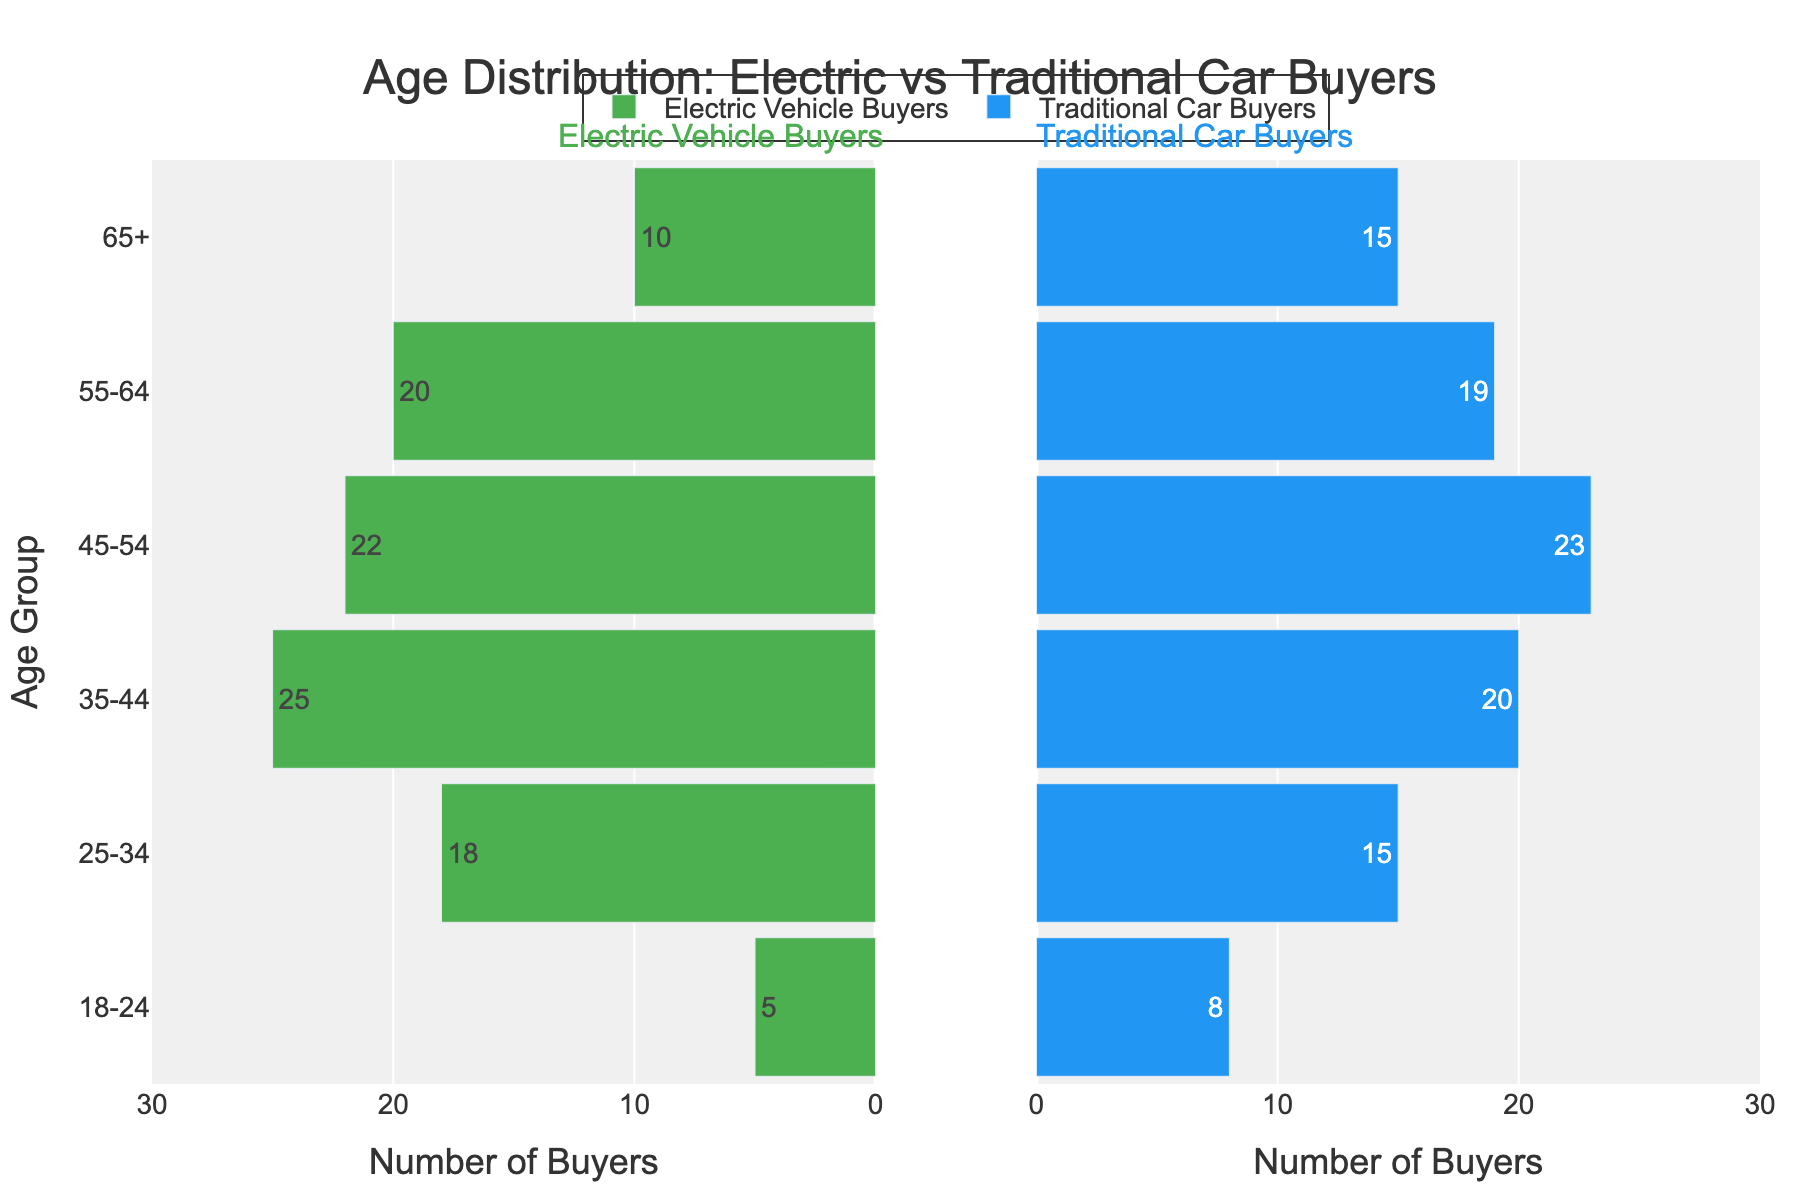What is the title of the figure? The title is displayed prominently at the top of the figure and indicates the data being visualized. It reads "Age Distribution: Electric vs Traditional Car Buyers."
Answer: Age Distribution: Electric vs Traditional Car Buyers Which age group has the highest number of electric vehicle buyers? By examining the green bars on the left side of the pyramid, the longest bar corresponds to the 35-44 age group with 25 buyers.
Answer: 35-44 Which age group has the lowest number of traditional car buyers? By examining the blue bars on the right side of the pyramid, the shortest bar corresponds to the 18-24 age group with 8 buyers.
Answer: 18-24 How many more buyers are there in the 25-34 age group compared to the 18-24 age group for electric vehicles? The electric vehicle buyers for the 25-34 age group are 18, while for the 18-24 age group are 5. The difference is 18 - 5 = 13.
Answer: 13 What is the total number of buyers for traditional cars in the 55-64 and 65+ age groups combined? Summing the buyers in the 55-64 (19) and 65+ (15) age groups for traditional cars gives 19 + 15 = 34.
Answer: 34 In which age group do electric vehicle buyers outnumber traditional car buyers the most? Subtract the number of traditional car buyers from electric vehicle buyers for each age group and find which has the maximum difference: 18-24: -3, 25-34: 3, 35-44: 5, 45-54: -1, 55-64: 1, 65+: -5. The age group 35-44 has the highest positive difference of 5.
Answer: 35-44 What is the range of the x-axis for electric vehicle buyers? The x-axis for electric vehicle buyers shows numbers from 0 to 30 but in reverse order, indicating the total range is 0 to 30 but displayed inverted.
Answer: 0 to 30 (inverted) Compare the number of electric and traditional car buyers for the 45-54 age group. The number of electric vehicle buyers for the 45-54 age group is 22, while the number of traditional car buyers is 23. Traditional car buyers outnumber electric vehicle buyers by 1.
Answer: 23 for traditional, 22 for electric Is the trend of electric vehicle buyers increasing or decreasing with age? By observing the green bars on the left, the number of buyers increases up until the 35-44 age group and then starts decreasing, indicating a rise and fall trend.
Answer: Increasing till 35-44, then decreasing How does the number of electric vehicle buyers in the 35-44 age group compare to the number of traditional car buyers in the same age group? For the 35-44 age group, there are 25 electric vehicle buyers and 20 traditional car buyers. Electric vehicle buyers outnumber traditional car buyers by 5.
Answer: Electric vehicle: 25, Traditional car: 20 